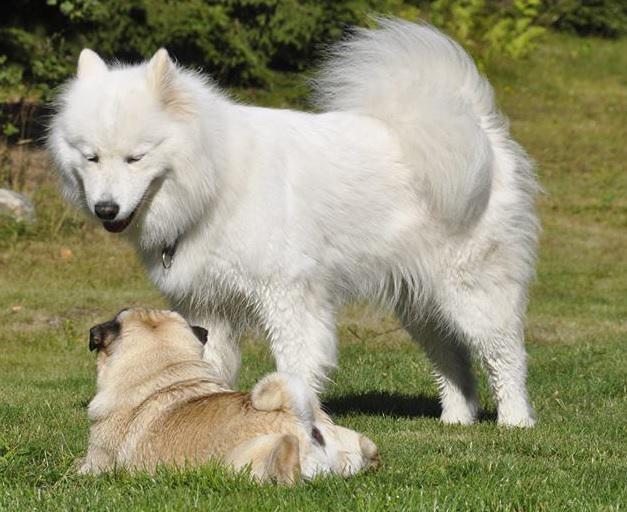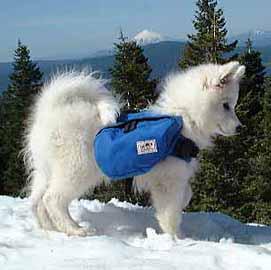The first image is the image on the left, the second image is the image on the right. Considering the images on both sides, is "An image shows a rightward facing dog wearing a pack." valid? Answer yes or no. Yes. The first image is the image on the left, the second image is the image on the right. Analyze the images presented: Is the assertion "A white dog has a colored canvas bag strapped to its back in one image, while the other image is of multiple dogs with no bags." valid? Answer yes or no. Yes. 